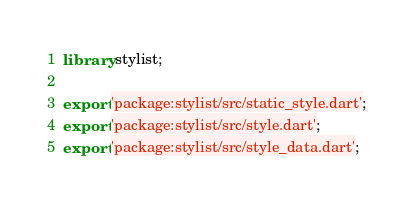<code> <loc_0><loc_0><loc_500><loc_500><_Dart_>library stylist;

export 'package:stylist/src/static_style.dart';
export 'package:stylist/src/style.dart';
export 'package:stylist/src/style_data.dart';
</code> 